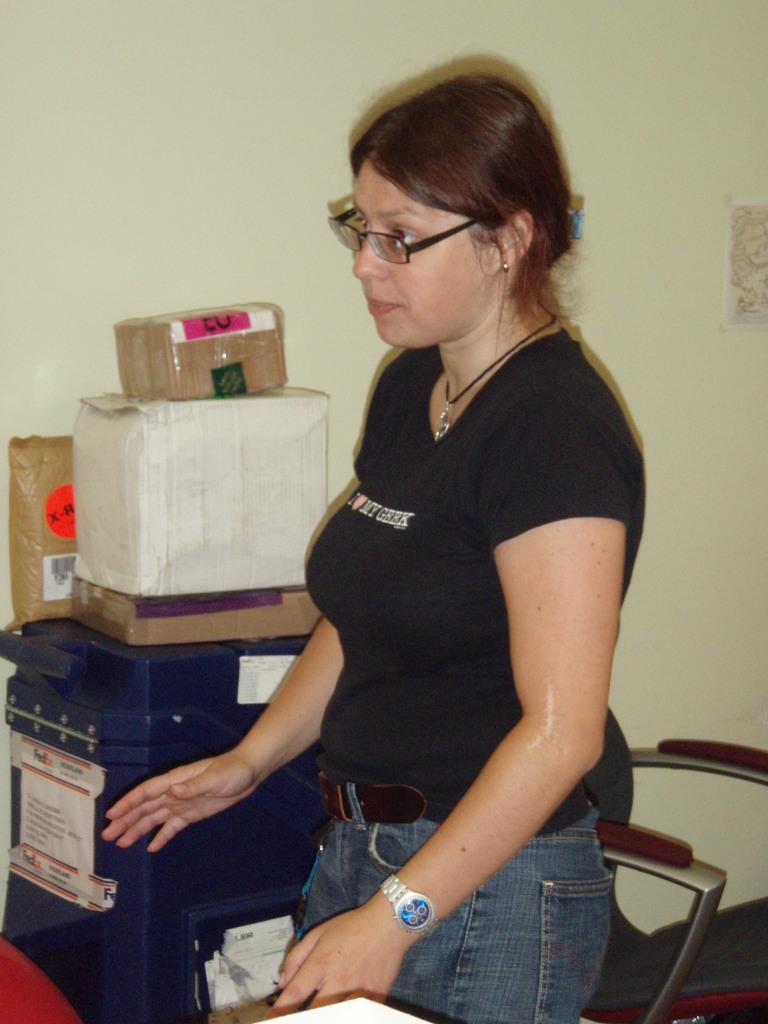Could you give a brief overview of what you see in this image? In this picture we can see a woman, here we can see a chair, boxes and some objects. In the background we can see a wall, sticker. 